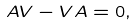Convert formula to latex. <formula><loc_0><loc_0><loc_500><loc_500>A V - V A = 0 ,</formula> 